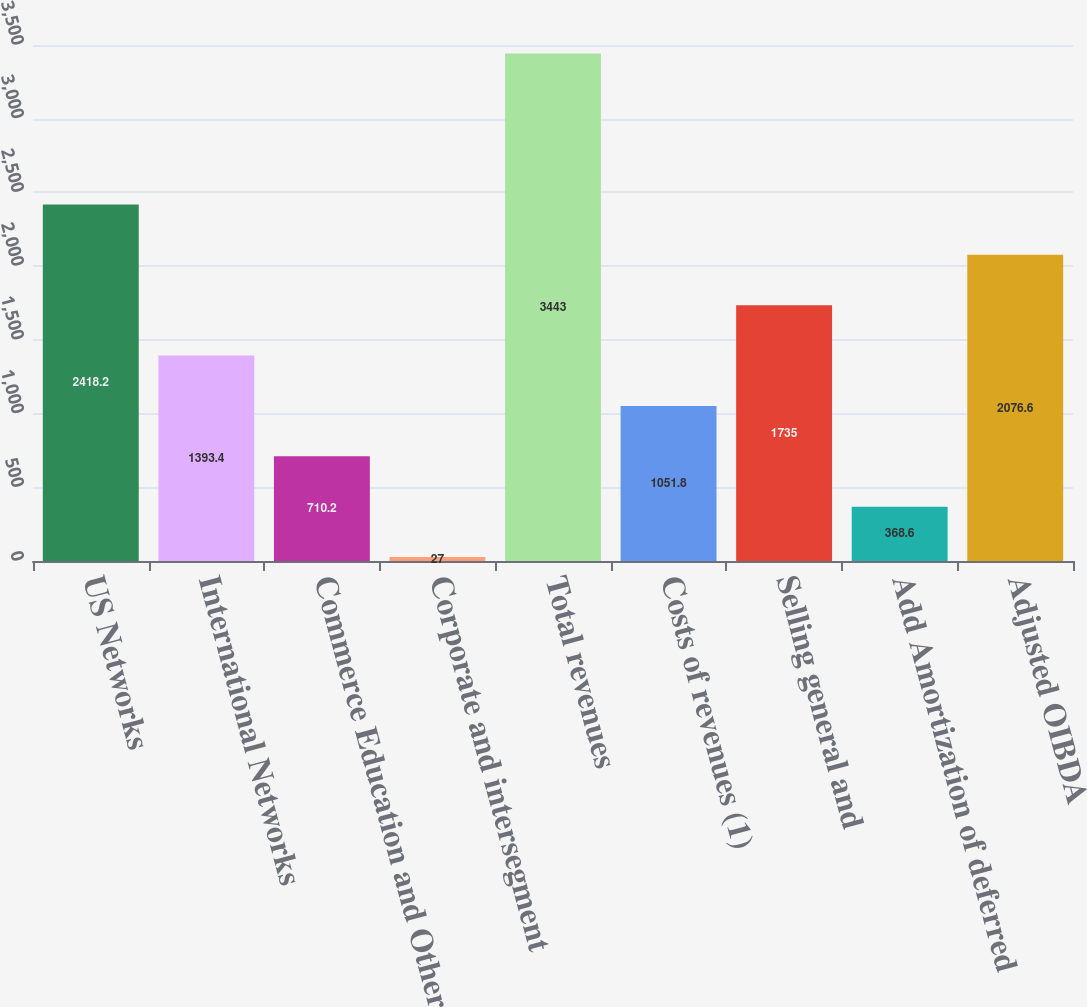Convert chart to OTSL. <chart><loc_0><loc_0><loc_500><loc_500><bar_chart><fcel>US Networks<fcel>International Networks<fcel>Commerce Education and Other<fcel>Corporate and intersegment<fcel>Total revenues<fcel>Costs of revenues (1)<fcel>Selling general and<fcel>Add Amortization of deferred<fcel>Adjusted OIBDA<nl><fcel>2418.2<fcel>1393.4<fcel>710.2<fcel>27<fcel>3443<fcel>1051.8<fcel>1735<fcel>368.6<fcel>2076.6<nl></chart> 